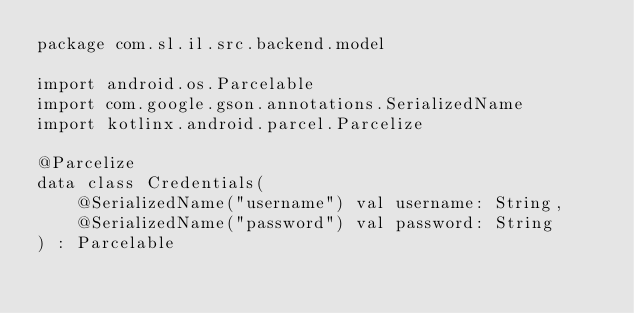<code> <loc_0><loc_0><loc_500><loc_500><_Kotlin_>package com.sl.il.src.backend.model

import android.os.Parcelable
import com.google.gson.annotations.SerializedName
import kotlinx.android.parcel.Parcelize

@Parcelize
data class Credentials(
    @SerializedName("username") val username: String,
    @SerializedName("password") val password: String
) : Parcelable
</code> 